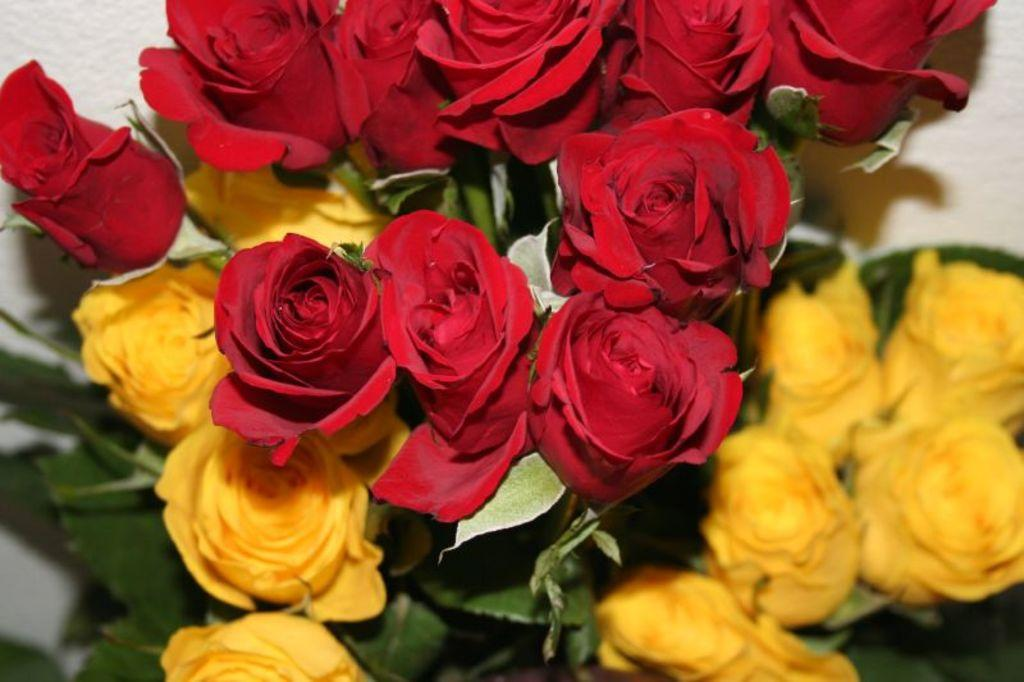What is the main subject of the image? The main subject of the image is a group of people sitting around a table. What are the people doing in the image? The people are having a meal together. Can you describe the setting of the image? The people are sitting around a table, which suggests they are in a dining area or at a gathering. What might be on the table besides the people? There may be plates, utensils, and food on the table, as they are having a meal together. What type of tiger can be seen drinking soda from a jar in the image? There is no tiger, soda, or jar present in the image. 